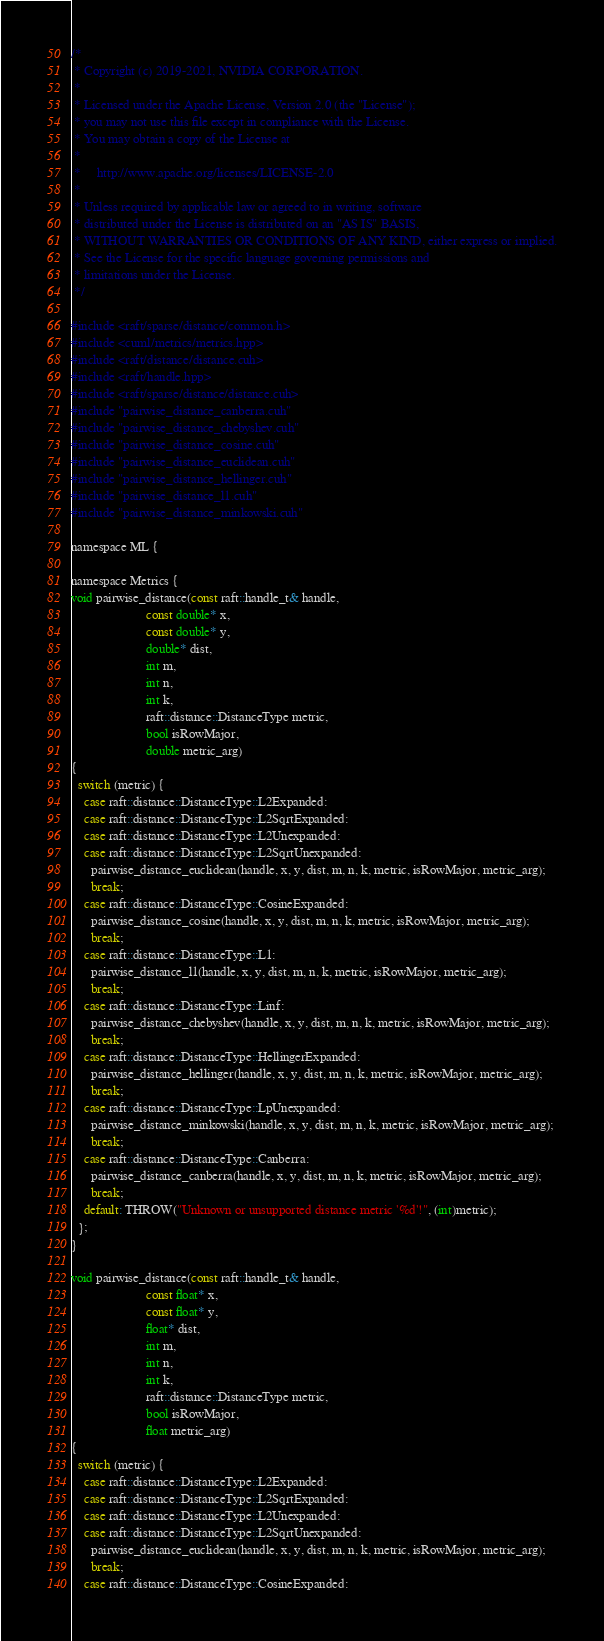<code> <loc_0><loc_0><loc_500><loc_500><_Cuda_>
/*
 * Copyright (c) 2019-2021, NVIDIA CORPORATION.
 *
 * Licensed under the Apache License, Version 2.0 (the "License");
 * you may not use this file except in compliance with the License.
 * You may obtain a copy of the License at
 *
 *     http://www.apache.org/licenses/LICENSE-2.0
 *
 * Unless required by applicable law or agreed to in writing, software
 * distributed under the License is distributed on an "AS IS" BASIS,
 * WITHOUT WARRANTIES OR CONDITIONS OF ANY KIND, either express or implied.
 * See the License for the specific language governing permissions and
 * limitations under the License.
 */

#include <raft/sparse/distance/common.h>
#include <cuml/metrics/metrics.hpp>
#include <raft/distance/distance.cuh>
#include <raft/handle.hpp>
#include <raft/sparse/distance/distance.cuh>
#include "pairwise_distance_canberra.cuh"
#include "pairwise_distance_chebyshev.cuh"
#include "pairwise_distance_cosine.cuh"
#include "pairwise_distance_euclidean.cuh"
#include "pairwise_distance_hellinger.cuh"
#include "pairwise_distance_l1.cuh"
#include "pairwise_distance_minkowski.cuh"

namespace ML {

namespace Metrics {
void pairwise_distance(const raft::handle_t& handle,
                       const double* x,
                       const double* y,
                       double* dist,
                       int m,
                       int n,
                       int k,
                       raft::distance::DistanceType metric,
                       bool isRowMajor,
                       double metric_arg)
{
  switch (metric) {
    case raft::distance::DistanceType::L2Expanded:
    case raft::distance::DistanceType::L2SqrtExpanded:
    case raft::distance::DistanceType::L2Unexpanded:
    case raft::distance::DistanceType::L2SqrtUnexpanded:
      pairwise_distance_euclidean(handle, x, y, dist, m, n, k, metric, isRowMajor, metric_arg);
      break;
    case raft::distance::DistanceType::CosineExpanded:
      pairwise_distance_cosine(handle, x, y, dist, m, n, k, metric, isRowMajor, metric_arg);
      break;
    case raft::distance::DistanceType::L1:
      pairwise_distance_l1(handle, x, y, dist, m, n, k, metric, isRowMajor, metric_arg);
      break;
    case raft::distance::DistanceType::Linf:
      pairwise_distance_chebyshev(handle, x, y, dist, m, n, k, metric, isRowMajor, metric_arg);
      break;
    case raft::distance::DistanceType::HellingerExpanded:
      pairwise_distance_hellinger(handle, x, y, dist, m, n, k, metric, isRowMajor, metric_arg);
      break;
    case raft::distance::DistanceType::LpUnexpanded:
      pairwise_distance_minkowski(handle, x, y, dist, m, n, k, metric, isRowMajor, metric_arg);
      break;
    case raft::distance::DistanceType::Canberra:
      pairwise_distance_canberra(handle, x, y, dist, m, n, k, metric, isRowMajor, metric_arg);
      break;
    default: THROW("Unknown or unsupported distance metric '%d'!", (int)metric);
  };
}

void pairwise_distance(const raft::handle_t& handle,
                       const float* x,
                       const float* y,
                       float* dist,
                       int m,
                       int n,
                       int k,
                       raft::distance::DistanceType metric,
                       bool isRowMajor,
                       float metric_arg)
{
  switch (metric) {
    case raft::distance::DistanceType::L2Expanded:
    case raft::distance::DistanceType::L2SqrtExpanded:
    case raft::distance::DistanceType::L2Unexpanded:
    case raft::distance::DistanceType::L2SqrtUnexpanded:
      pairwise_distance_euclidean(handle, x, y, dist, m, n, k, metric, isRowMajor, metric_arg);
      break;
    case raft::distance::DistanceType::CosineExpanded:</code> 